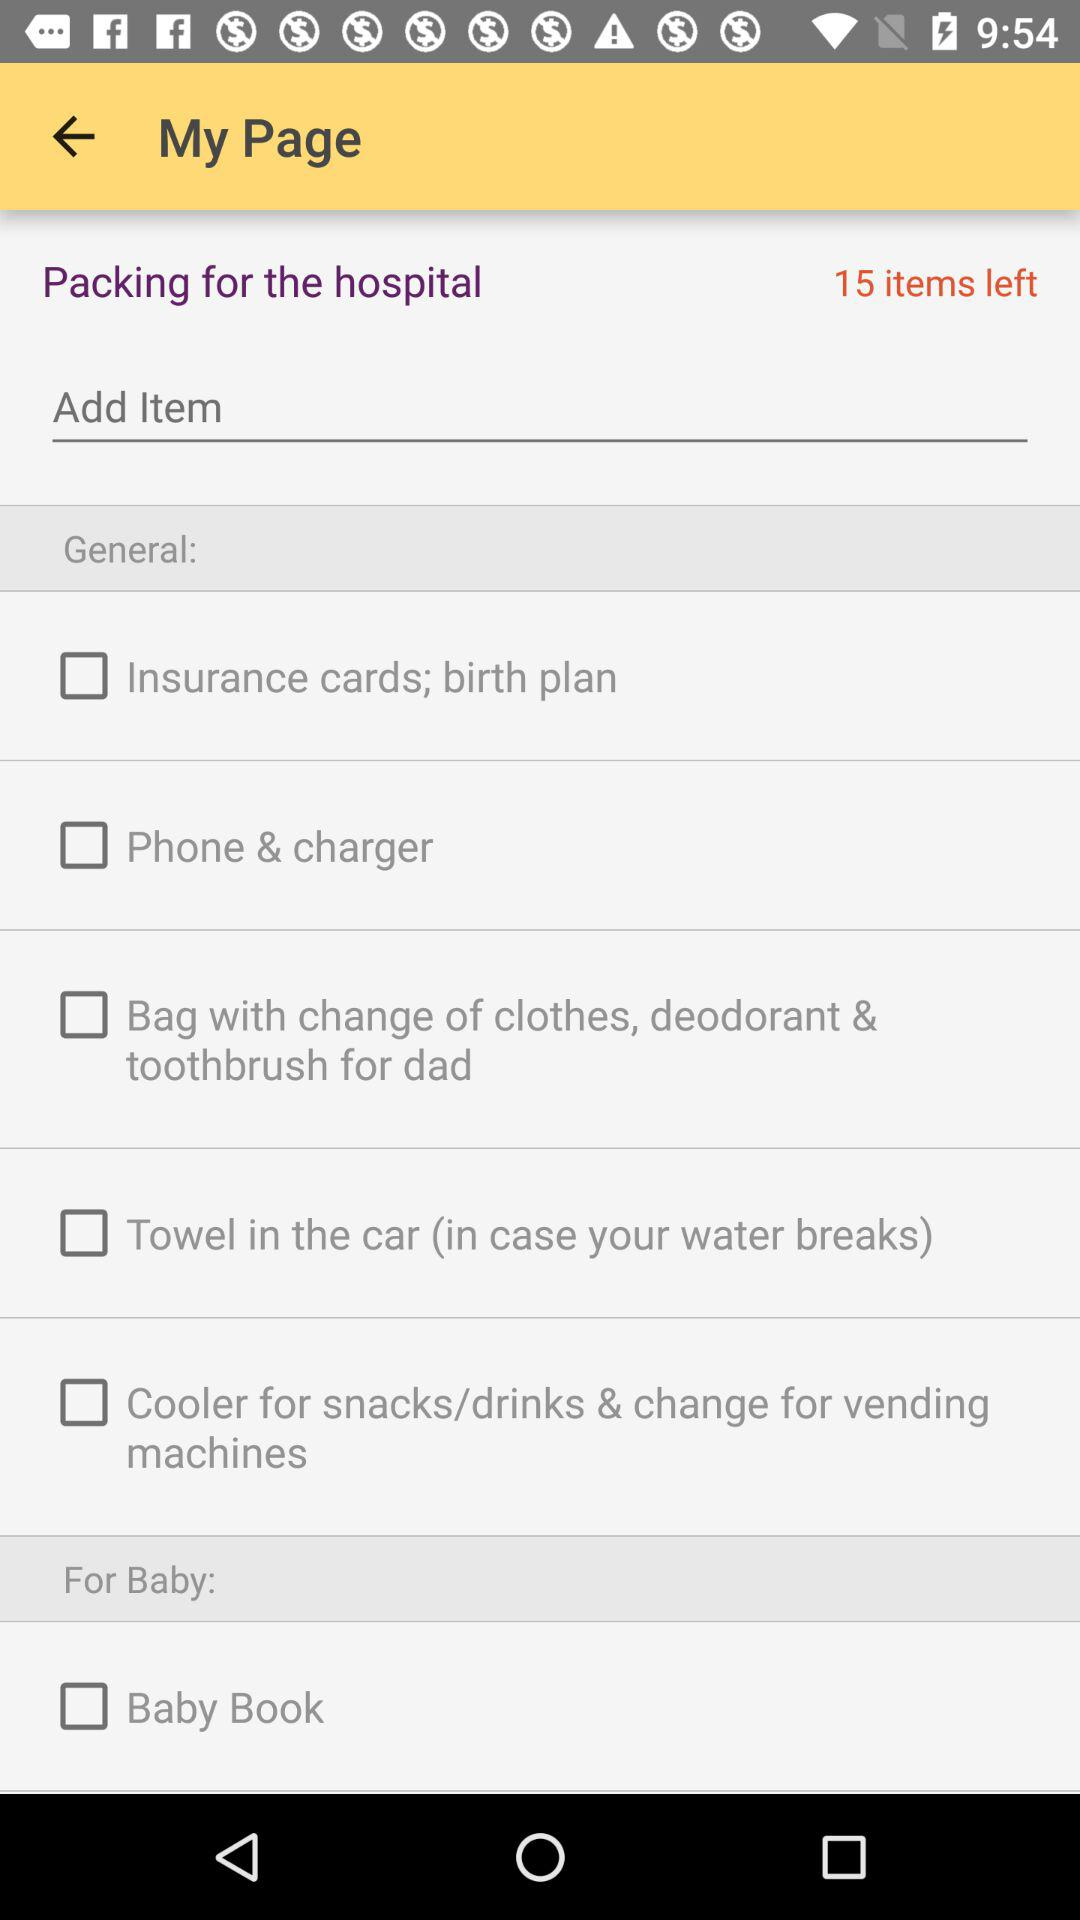How many items are left to pack?
Answer the question using a single word or phrase. 15 